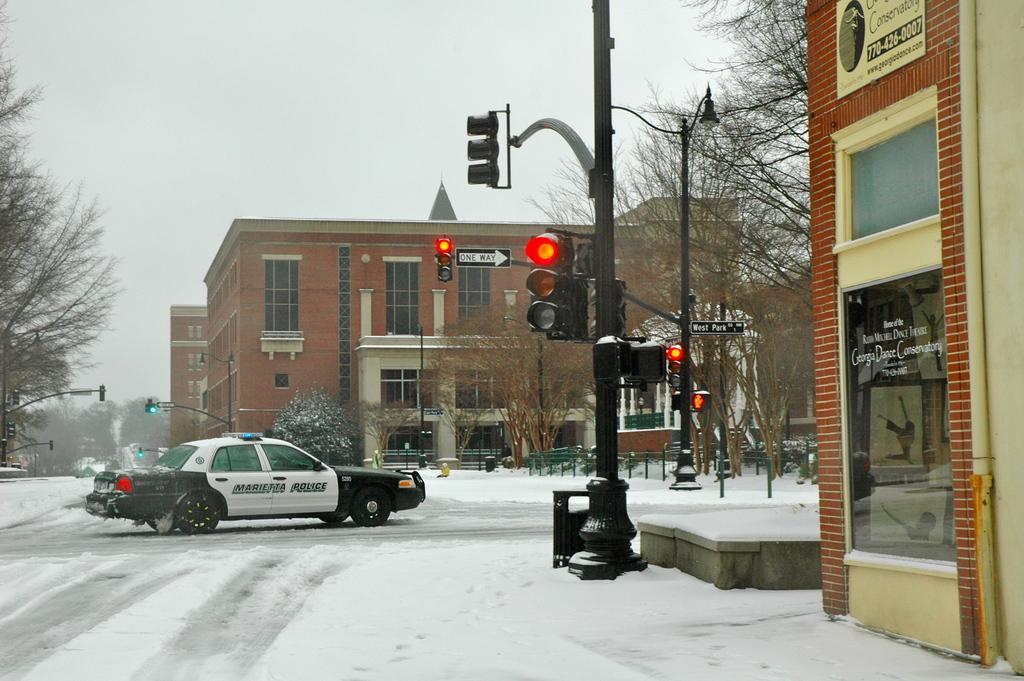Describe this image in one or two sentences. In this image, we can see traffic signals, poles, sign boards, trees, buildings, walls, glass windows and few objects. Here we can see snow and vehicle on the road. Background there is the sky. 